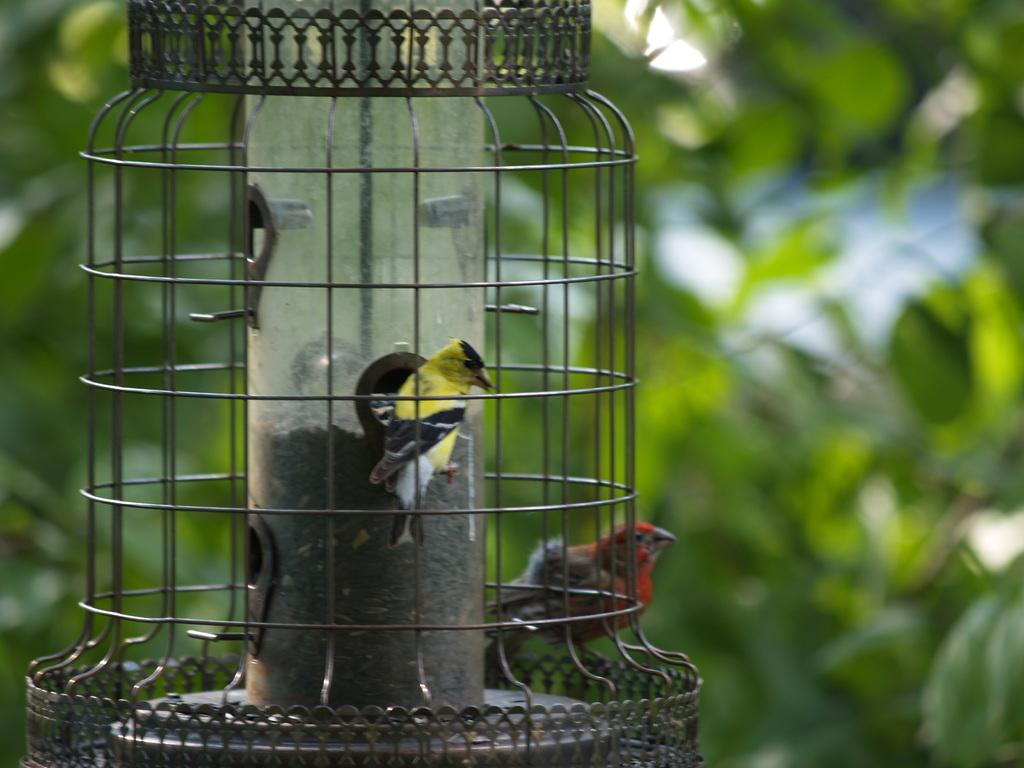How many birds are present in the image? There are two birds in the image. Where are the birds located? The birds are in a cage. What can be seen in the background of the image? There are plants in the background of the image. What type of tub can be seen in the image? There is no tub present in the image; it features two birds in a cage with plants in the background. 